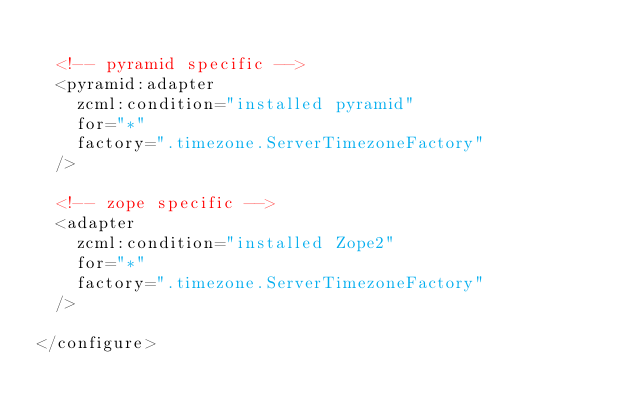<code> <loc_0><loc_0><loc_500><loc_500><_XML_>
  <!-- pyramid specific -->
  <pyramid:adapter
    zcml:condition="installed pyramid"
    for="*"
    factory=".timezone.ServerTimezoneFactory"
  />

  <!-- zope specific -->
  <adapter
    zcml:condition="installed Zope2"
    for="*"
    factory=".timezone.ServerTimezoneFactory"
  />

</configure>
</code> 